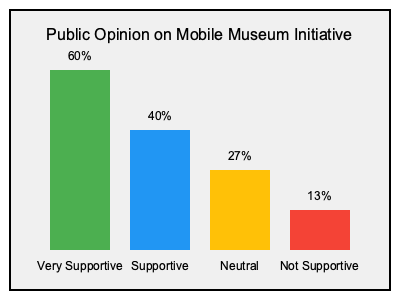Based on the infographic, what percentage of the population is at least supportive of the mobile museum initiative, and how might this information influence policy decisions regarding cultural events? To answer this question, we need to follow these steps:

1. Identify the categories that represent "at least supportive":
   - "Very Supportive" (60%)
   - "Supportive" (40%)

2. Calculate the sum of these percentages:
   $60\% + 40\% = 100\%$

3. Interpret the result:
   100% of the population is at least supportive of the mobile museum initiative.

4. Consider the policy implications:
   - High public support suggests a strong mandate for implementing the mobile museum project.
   - This overwhelming support could justify allocating more resources to cultural initiatives.
   - The data could be used to persuade skeptical colleagues or stakeholders about the importance of the project.
   - It may encourage the expansion of similar cultural outreach programs.
   - The strong public backing could be leveraged to seek additional funding or partnerships for the initiative.

5. Potential policy decisions:
   - Increase budget allocation for the mobile museum project.
   - Expand the scope of the mobile museum to reach more areas.
   - Use this as a model for other cultural initiatives.
   - Develop long-term strategies for sustaining and growing cultural programs.
   - Create public-private partnerships to enhance the project's impact and sustainability.

This high level of support provides a strong foundation for policy-makers to prioritize and invest in cultural events and mobile museum initiatives, potentially leading to more diverse and accessible cultural experiences for the public.
Answer: 100%; strong mandate for cultural initiatives 